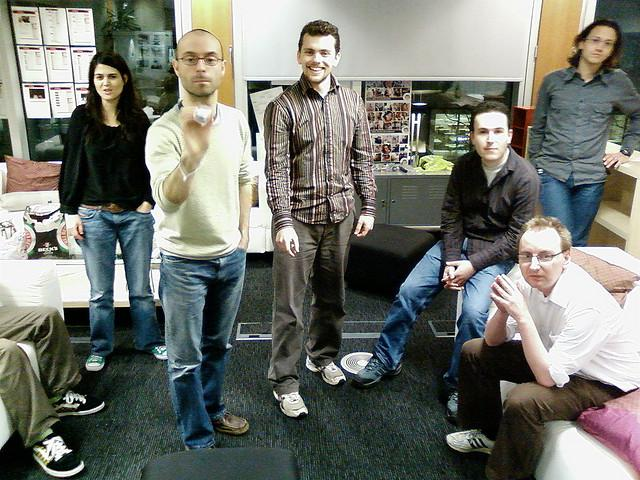Where is the group focusing their attention?

Choices:
A) poster
B) screen
C) speaker
D) performer screen 